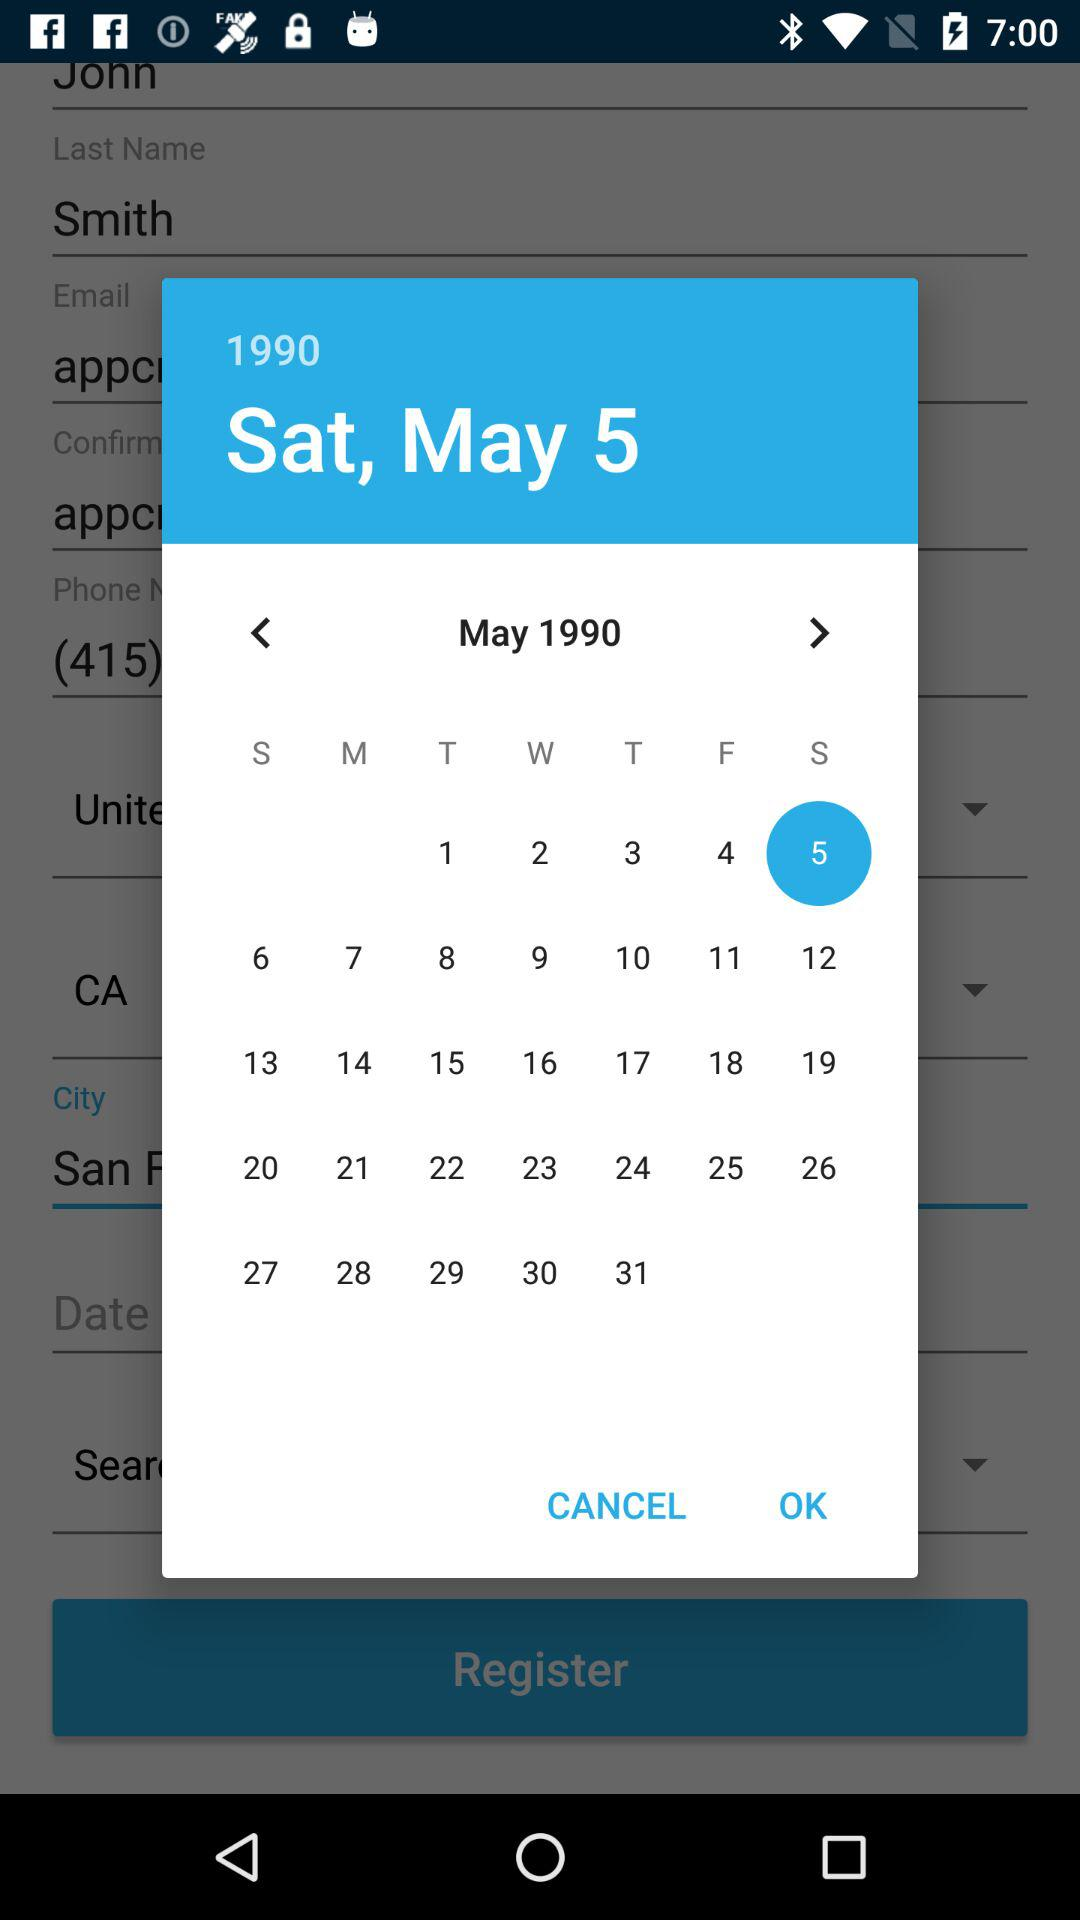Which date is selected on the calendar? The selected date is Sunday, May 5, 1990. 